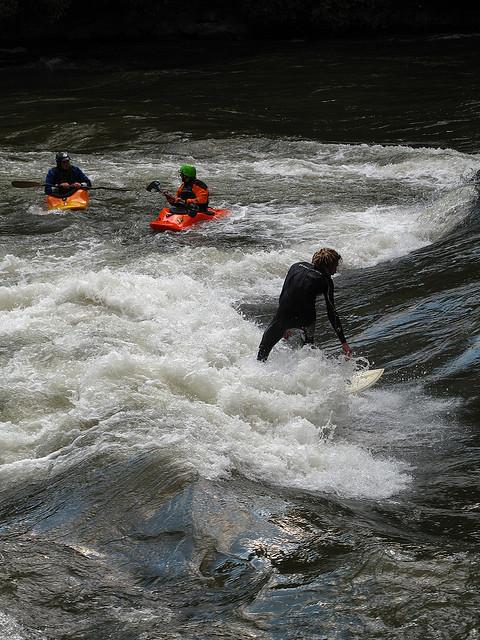What is the person to the far left sitting on? kayak 